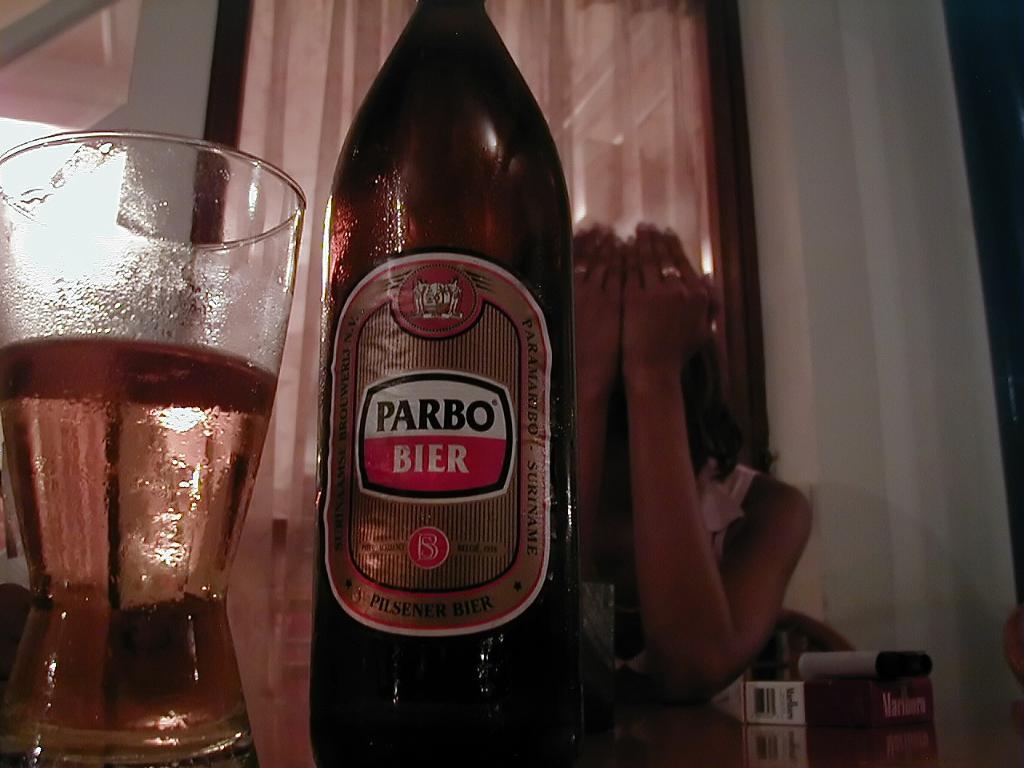What variety of beer is this?
Your answer should be very brief. Parbo bier. 